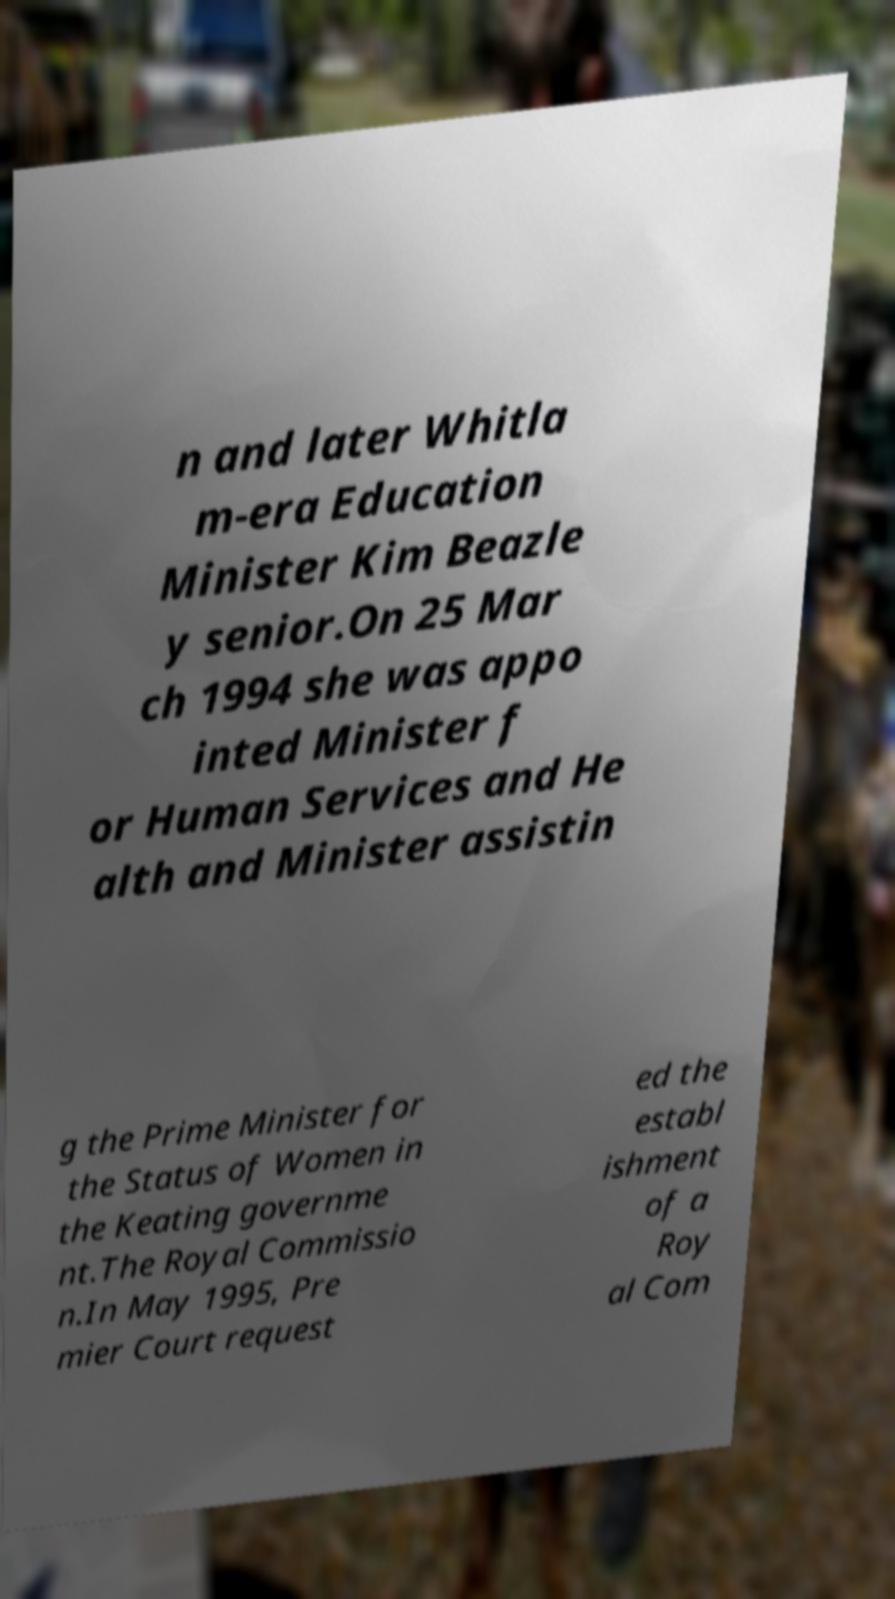Can you read and provide the text displayed in the image?This photo seems to have some interesting text. Can you extract and type it out for me? n and later Whitla m-era Education Minister Kim Beazle y senior.On 25 Mar ch 1994 she was appo inted Minister f or Human Services and He alth and Minister assistin g the Prime Minister for the Status of Women in the Keating governme nt.The Royal Commissio n.In May 1995, Pre mier Court request ed the establ ishment of a Roy al Com 